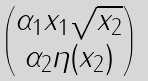Convert formula to latex. <formula><loc_0><loc_0><loc_500><loc_500>\begin{pmatrix} \alpha _ { 1 } x _ { 1 } \sqrt { x _ { 2 } } \\ \alpha _ { 2 } \eta ( x _ { 2 } ) \end{pmatrix}</formula> 